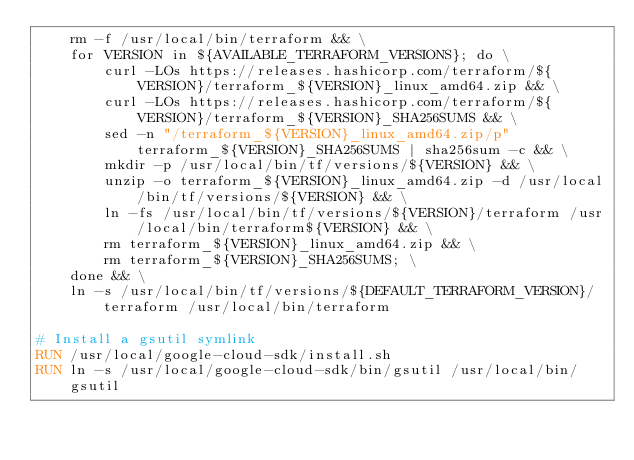<code> <loc_0><loc_0><loc_500><loc_500><_Dockerfile_>    rm -f /usr/local/bin/terraform && \
    for VERSION in ${AVAILABLE_TERRAFORM_VERSIONS}; do \
        curl -LOs https://releases.hashicorp.com/terraform/${VERSION}/terraform_${VERSION}_linux_amd64.zip && \
        curl -LOs https://releases.hashicorp.com/terraform/${VERSION}/terraform_${VERSION}_SHA256SUMS && \
        sed -n "/terraform_${VERSION}_linux_amd64.zip/p" terraform_${VERSION}_SHA256SUMS | sha256sum -c && \
        mkdir -p /usr/local/bin/tf/versions/${VERSION} && \
        unzip -o terraform_${VERSION}_linux_amd64.zip -d /usr/local/bin/tf/versions/${VERSION} && \
        ln -fs /usr/local/bin/tf/versions/${VERSION}/terraform /usr/local/bin/terraform${VERSION} && \
        rm terraform_${VERSION}_linux_amd64.zip && \
        rm terraform_${VERSION}_SHA256SUMS; \
    done && \
    ln -s /usr/local/bin/tf/versions/${DEFAULT_TERRAFORM_VERSION}/terraform /usr/local/bin/terraform

# Install a gsutil symlink
RUN /usr/local/google-cloud-sdk/install.sh
RUN ln -s /usr/local/google-cloud-sdk/bin/gsutil /usr/local/bin/gsutil
</code> 